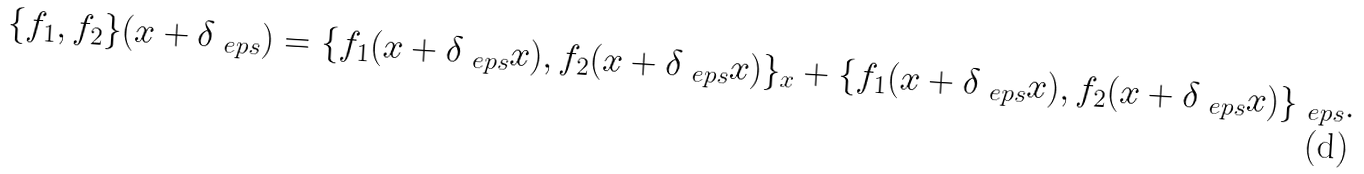Convert formula to latex. <formula><loc_0><loc_0><loc_500><loc_500>\{ f _ { 1 } , f _ { 2 } \} ( x + \delta _ { \ e p s } ) = \{ f _ { 1 } ( x + \delta _ { \ e p s } x ) , f _ { 2 } ( x + \delta _ { \ e p s } x ) \} _ { x } + \{ f _ { 1 } ( x + \delta _ { \ e p s } x ) , f _ { 2 } ( x + \delta _ { \ e p s } x ) \} _ { \ e p s } .</formula> 